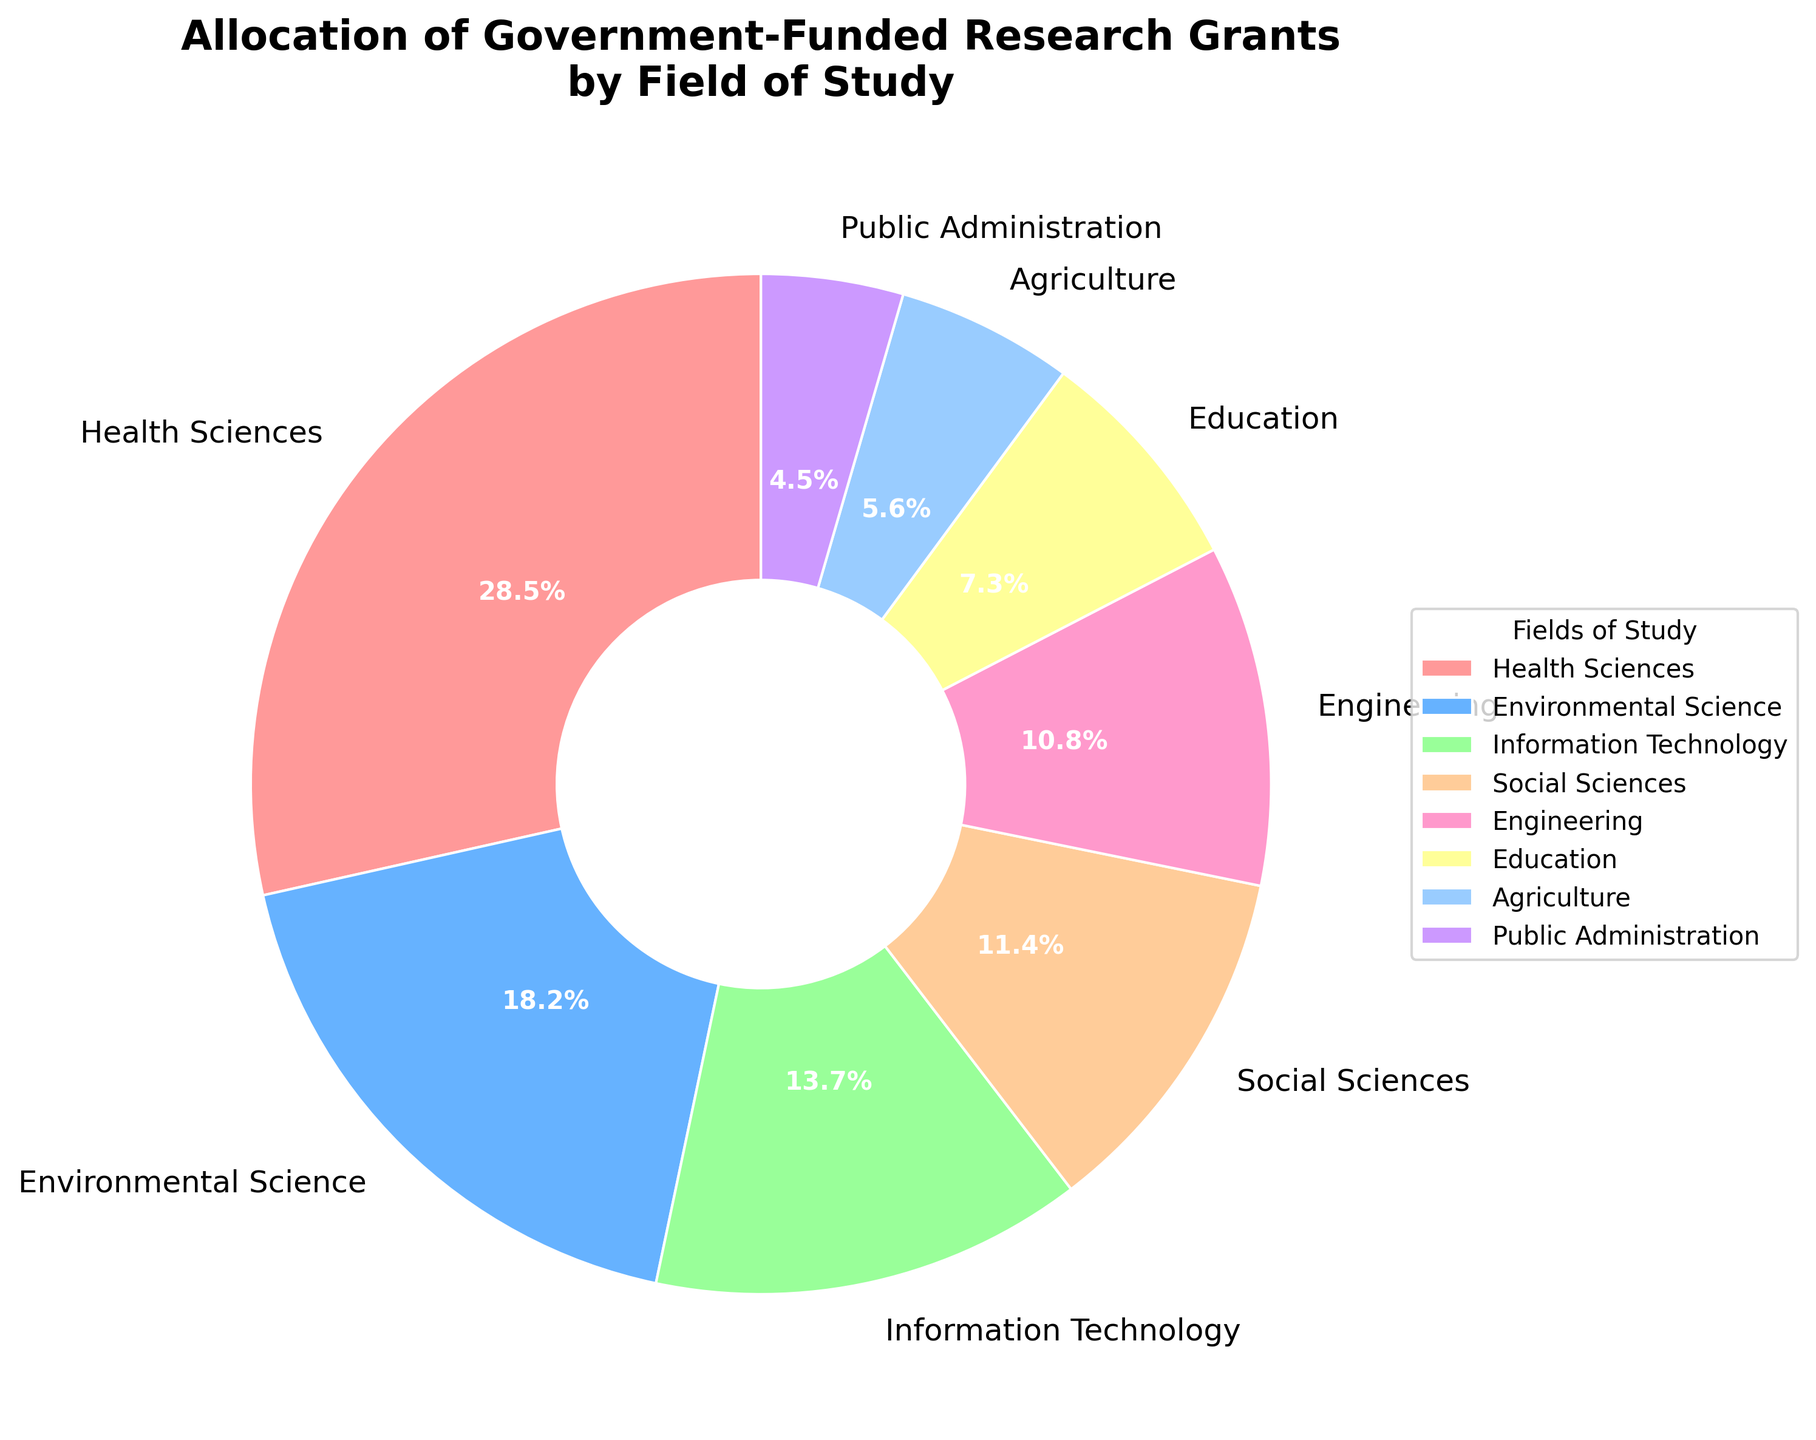Which field receives the highest percentage of government-funded research grants? The field with the highest percentage is directly indicated in the pie chart, which is Health Sciences with 28.5%.
Answer: Health Sciences Which field receives the lowest percentage of government-funded research grants? The field with the lowest percentage is directly indicated in the pie chart, which is Public Administration with 4.5%.
Answer: Public Administration What is the combined percentage of grants for Information Technology and Education? From the pie chart, Information Technology is 13.7% and Education is 7.3%. Adding these together gives 13.7% + 7.3% = 21%.
Answer: 21% How much higher is the percentage of grants in Health Sciences compared to Engineering? Health Sciences has 28.5% and Engineering has 10.8%. The difference is 28.5% - 10.8% = 17.7%.
Answer: 17.7% If we combined the percentages of Agriculture and Public Administration, would it surpass the percentage for Environmental Science? Agriculture has 5.6% and Public Administration has 4.5%. Combining these gives 5.6% + 4.5% = 10.1%, which does not surpass Environmental Science's 18.2%.
Answer: No Which fields have a percentage allocation between 10% and 20%? By examining the pie chart, the fields that fall in this range are Environmental Science (18.2%), Information Technology (13.7%), Social Sciences (11.4%), and Engineering (10.8%).
Answer: Environmental Science, Information Technology, Social Sciences, Engineering What is the average percentage allocation among all fields? To find the average percentage, sum all the percentages and divide by the number of fields. The sum is: 28.5 + 18.2 + 13.7 + 11.4 + 10.8 + 7.3 + 5.6 + 4.5 = 100%. Since there are 8 fields, the average is 100% / 8 = 12.5%.
Answer: 12.5% What is the ratio of the percentage allocation between Health Sciences and Agriculture? Health Sciences has 28.5% and Agriculture has 5.6%. The ratio is 28.5 / 5.6 which simplifies to approximately 5.1.
Answer: 5.1 